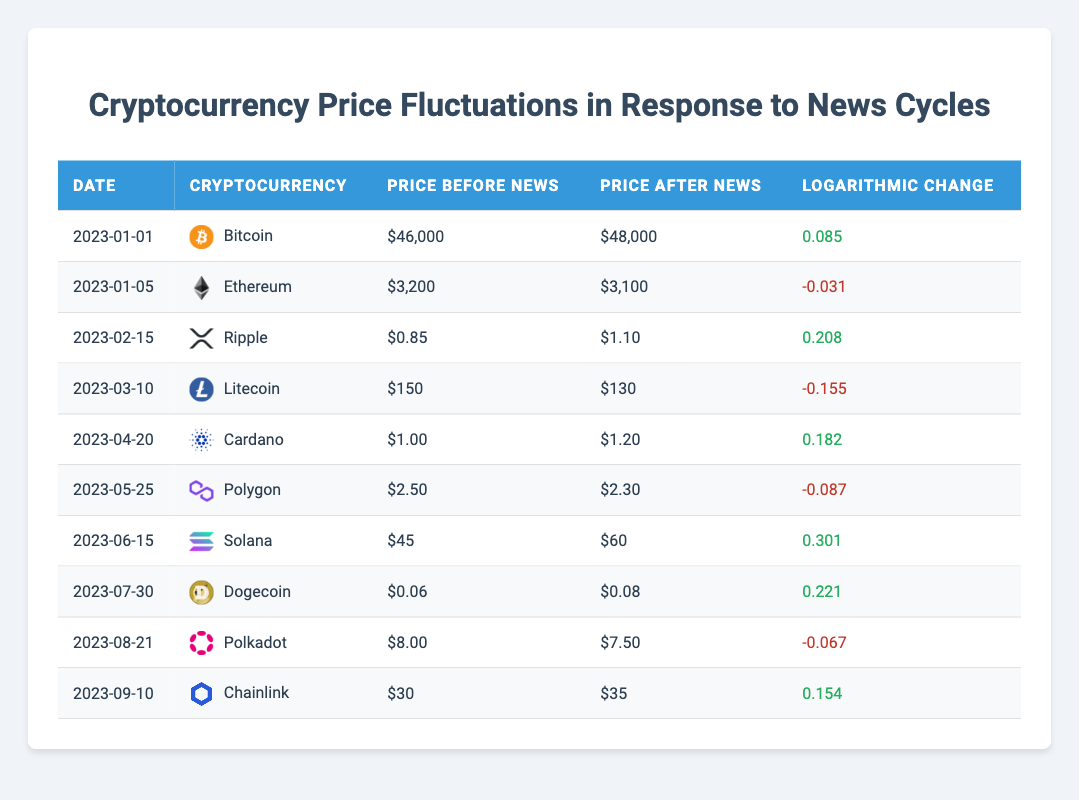What is the price change of Ethereum before and after the news on January 5, 2023? The price before the news was $3,200 and after the news, it was $3,100. To find the change, we subtract the price after from the price before: $3,200 - $3,100 = $100. Hence, the price decreased by $100.
Answer: Price decreased by $100 Which cryptocurrency had the highest logarithmic price change? Upon reviewing the logarithmic change values, we find that Solana had the highest value at 0.301. This is greater than all other values listed in the table.
Answer: Solana Was there any cryptocurrency that experienced a negative logarithmic price change after being affected by news? We need to check the logarithmic change column for negative values. The negative values are for Ethereum (-0.031), Litecoin (-0.155), Polygon (-0.087), and Polkadot (-0.067), indicating that multiple cryptocurrencies experienced a negative change.
Answer: Yes What is the average logarithmic change across all cryptocurrencies listed in the table? To calculate the average, we sum all the logarithmic change values: 0.085 + (-0.031) + 0.208 + (-0.155) + 0.182 + (-0.087) + 0.301 + 0.221 + (-0.067) + 0.154 = 0.510. Then, dividing this by the number of cryptocurrencies (10), we get 0.510 / 10 = 0.051.
Answer: 0.051 Which cryptocurrency had the largest price increase, and what was its logarithmic change? The largest price increase occurred with Solana, which rose from $45 to $60. This corresponds to a logarithmic change of 0.301, which is verified by referencing the price data from the table.
Answer: Solana, 0.301 